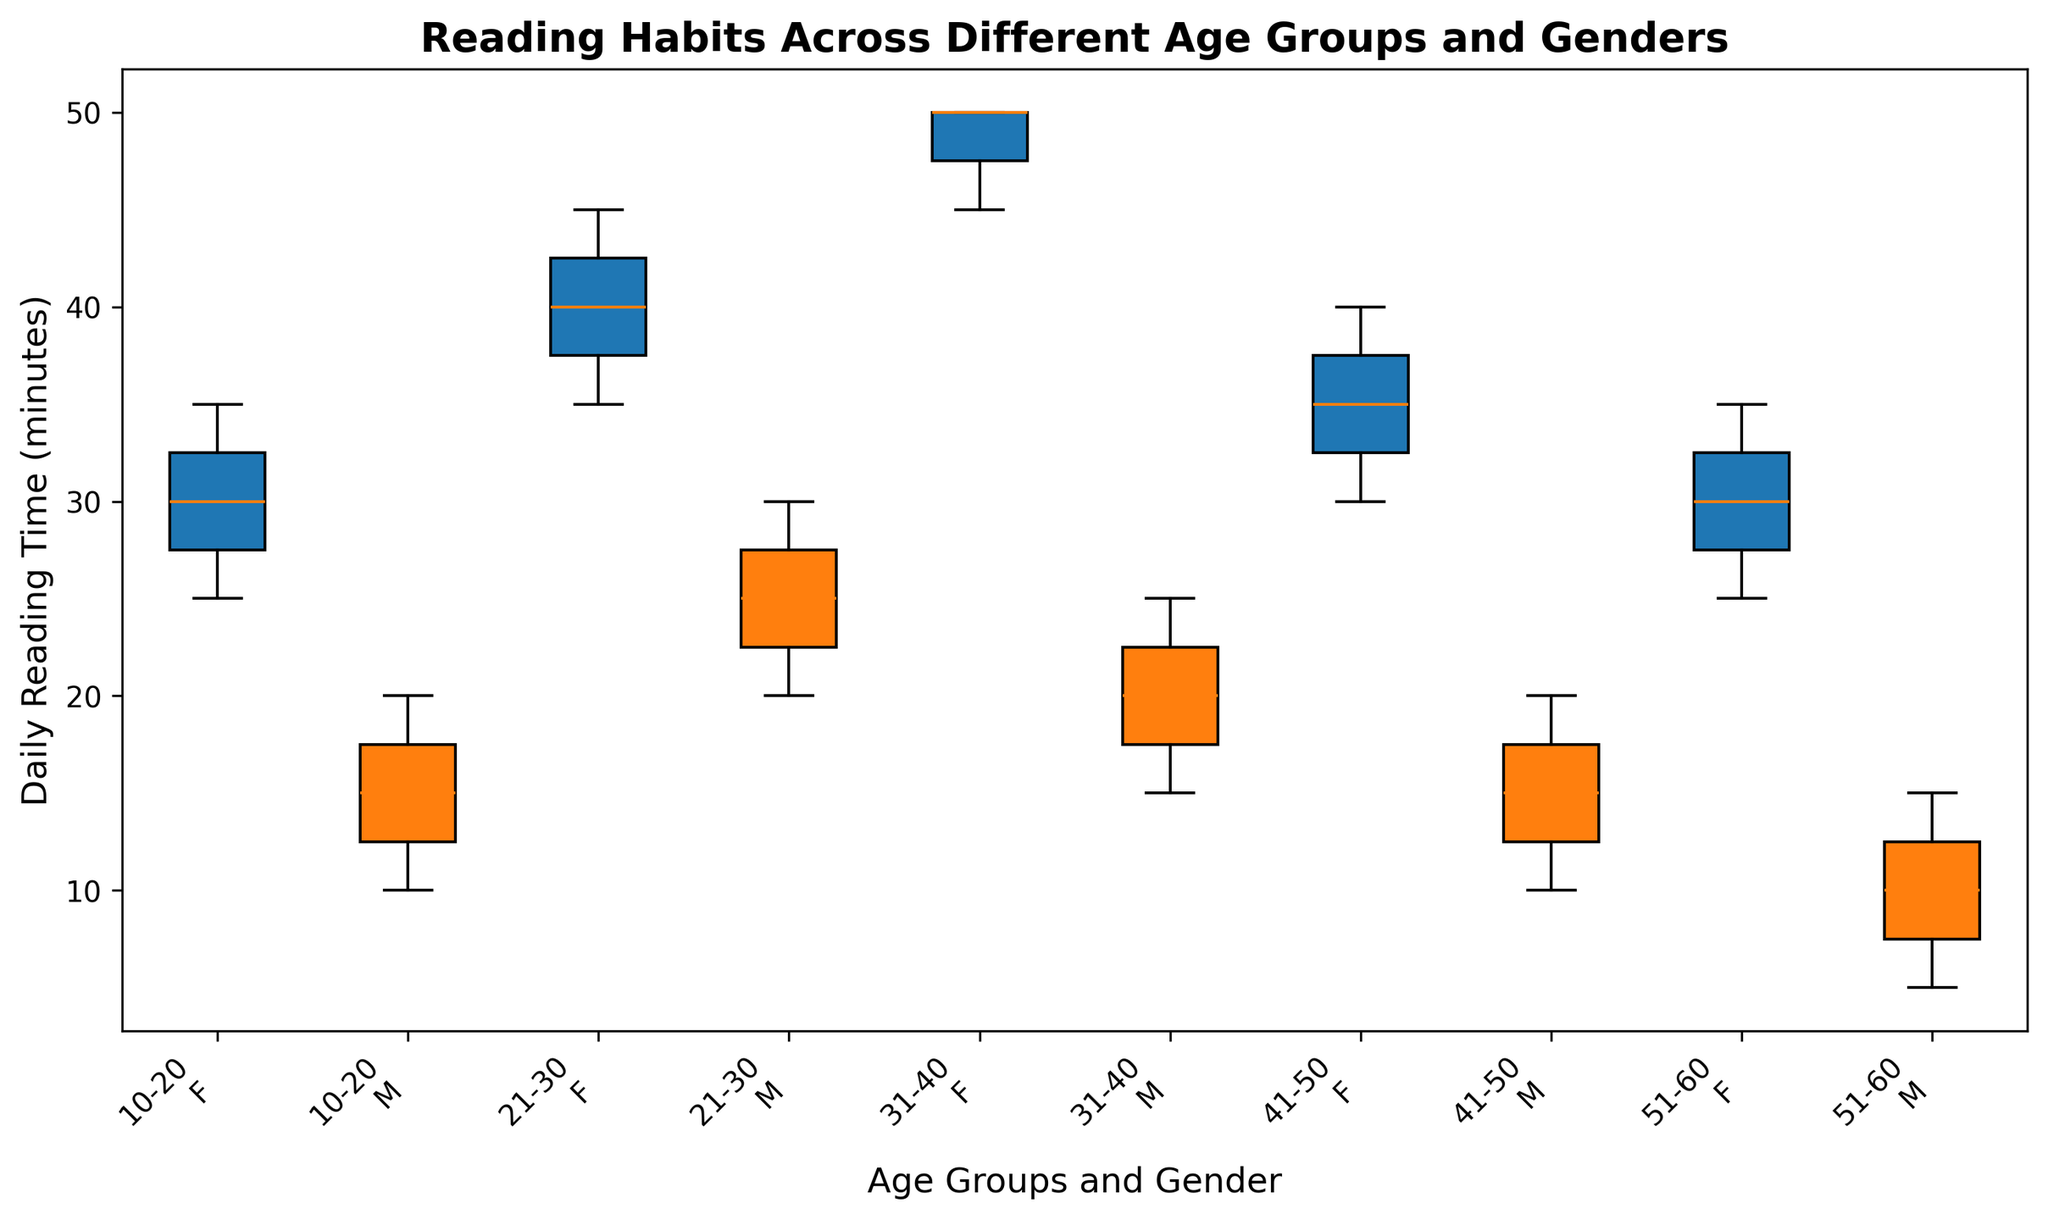Which age group and gender read the most on average? By looking at the medians from the box plots, we can determine the average reading time for each group. The highest median can indicate the group that reads the most on average. The 31-40 age group females have a higher median in their box plot compared to other groups.
Answer: 31-40 females Which gender has higher variability in reading times in the 10-20 age group? Variability can be assessed by looking at the interquartile range (IQR), represented by the length of the box in the box plot. For the age group 10-20, females show a larger IQR compared to males, indicating higher variability.
Answer: Females What is the median daily reading time for males in the 21-30 age group? The median is the line inside the box plot. For males in the 21-30 age group, this line falls at 25 minutes.
Answer: 25 minutes How does the reading habit of males change from age group 41-50 to 51-60? By comparing the box plots for these two age groups for males, we see that the median daily reading time decreases from about 15 minutes in the 41-50 age group to about 10 minutes in the 51-60 age group.
Answer: Decreases Which age group shows the smallest interquartile range (IQR) for females? The interquartile range (IQR) can be visualized as the height of the box in each box plot. The 51-60 age group for females has the smallest IQR as the box is the shortest.
Answer: 51-60 Do males or females in the 31-40 age group have a greater range of reading times? Range is determined by the distance between the lowest and highest points (whiskers) of the box plot. For the 31-40 age group, females have a greater range as their whiskers extend further than those of males.
Answer: Females In which age group do females have a significantly higher median reading time than males? By comparing the medians across age groups, females in the 31-40 age group have a significantly higher median reading time compared to males of the same age group.
Answer: 31-40 What is the central tendency of reading times for both genders in the 10-20 age group? The central tendency can be understood by looking at the position of the median lines within the box plots. For both genders in the 10-20 age group, the median time for males is about 15 minutes, and for females, it is around 30 minutes.
Answer: Males: 15 minutes, Females: 30 minutes Which age group has the most similar reading habits between genders? Similarity can be determined by comparing the medians, IQR, and overall distribution of the box plots for both genders. The 51-60 age group shows similar medians and a similar spread of reading times for both genders.
Answer: 51-60 Which group shows the lowest median reading time overall? Comparing the median lines across all box plots, the males in the 51-60 age group show the lowest median daily reading time at 10 minutes.
Answer: Males, 51-60 